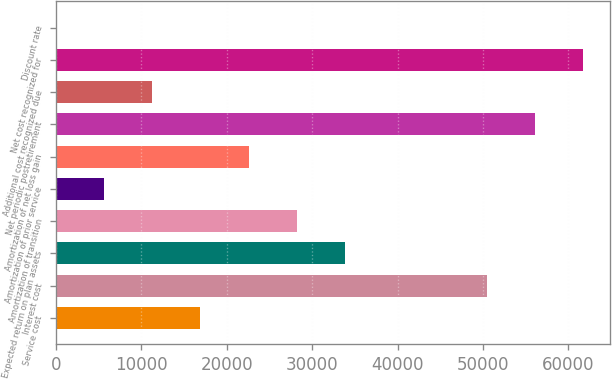Convert chart to OTSL. <chart><loc_0><loc_0><loc_500><loc_500><bar_chart><fcel>Service cost<fcel>Interest cost<fcel>Expected return on plan assets<fcel>Amortization of transition<fcel>Amortization of prior service<fcel>Amortization of net loss gain<fcel>Net periodic postretirement<fcel>Additional cost recognized due<fcel>Net cost recognized for<fcel>Discount rate<nl><fcel>16916.7<fcel>50475<fcel>33827.4<fcel>28190.5<fcel>5642.9<fcel>22553.6<fcel>56111.9<fcel>11279.8<fcel>61748.8<fcel>6<nl></chart> 